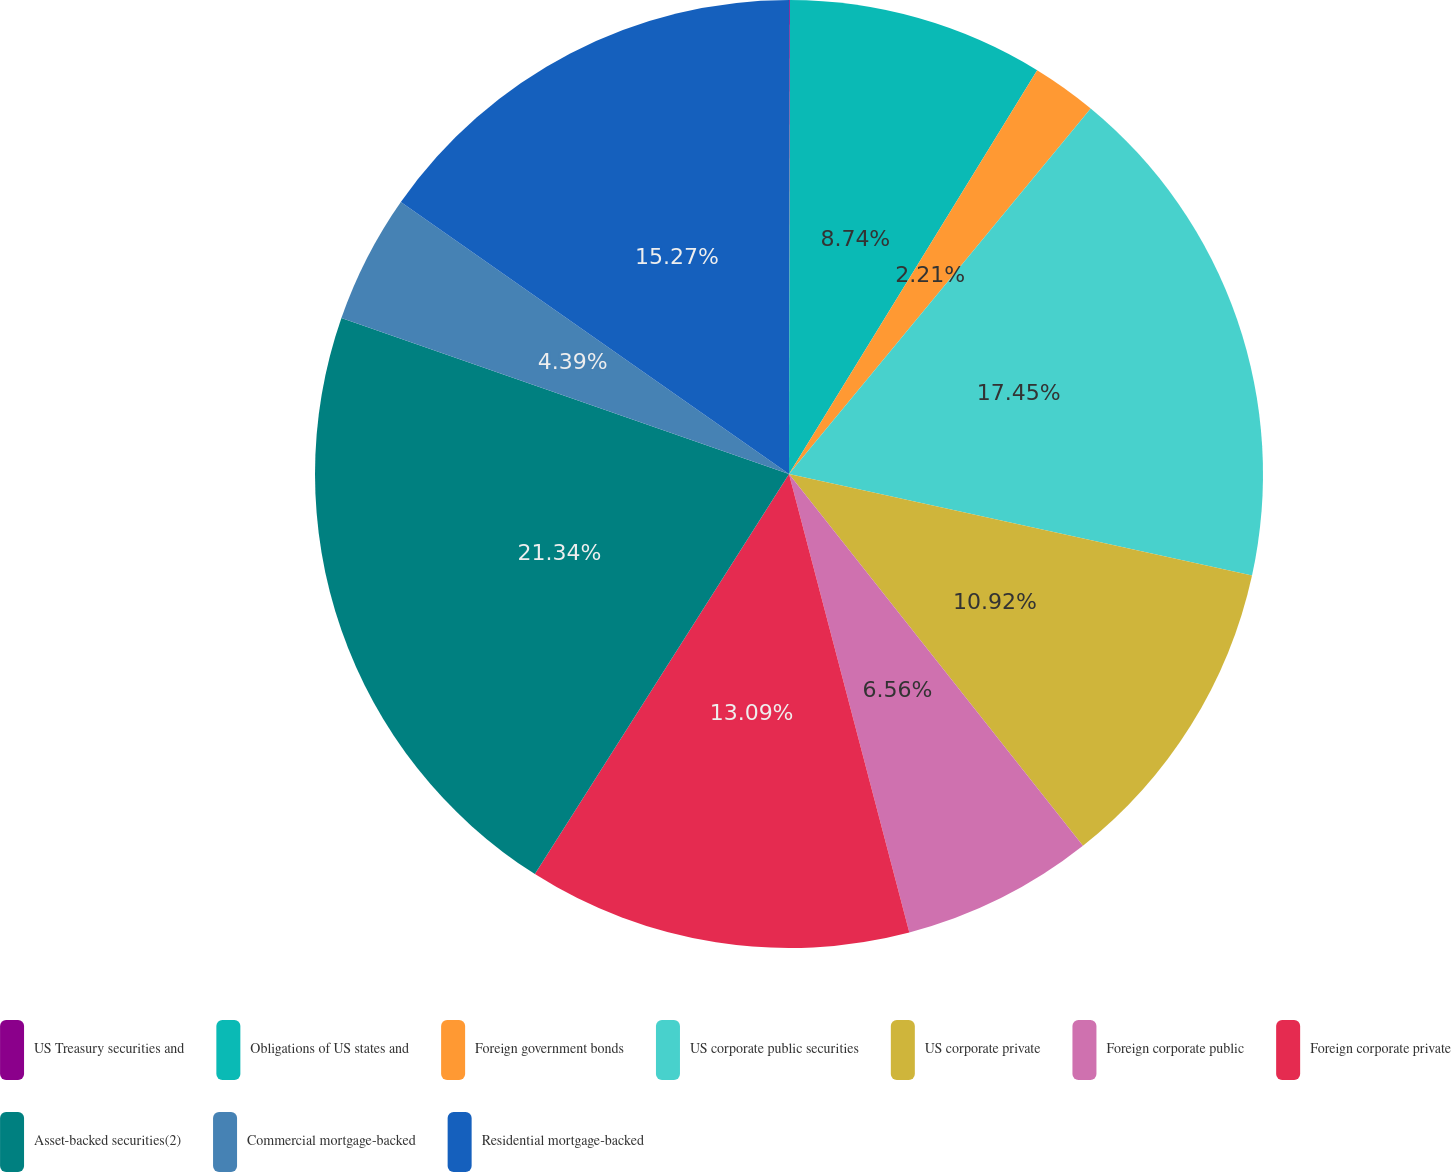<chart> <loc_0><loc_0><loc_500><loc_500><pie_chart><fcel>US Treasury securities and<fcel>Obligations of US states and<fcel>Foreign government bonds<fcel>US corporate public securities<fcel>US corporate private<fcel>Foreign corporate public<fcel>Foreign corporate private<fcel>Asset-backed securities(2)<fcel>Commercial mortgage-backed<fcel>Residential mortgage-backed<nl><fcel>0.03%<fcel>8.74%<fcel>2.21%<fcel>17.45%<fcel>10.92%<fcel>6.56%<fcel>13.09%<fcel>21.33%<fcel>4.39%<fcel>15.27%<nl></chart> 